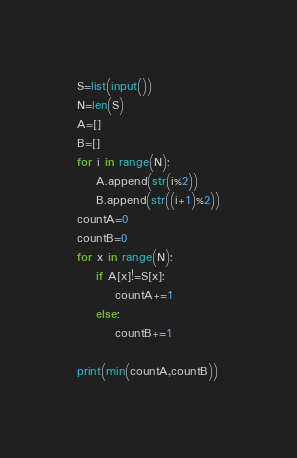Convert code to text. <code><loc_0><loc_0><loc_500><loc_500><_Python_>S=list(input())
N=len(S)
A=[]
B=[]
for i in range(N):
    A.append(str(i%2))
    B.append(str((i+1)%2))
countA=0
countB=0
for x in range(N):
    if A[x]!=S[x]:
        countA+=1
    else:
        countB+=1

print(min(countA,countB))</code> 